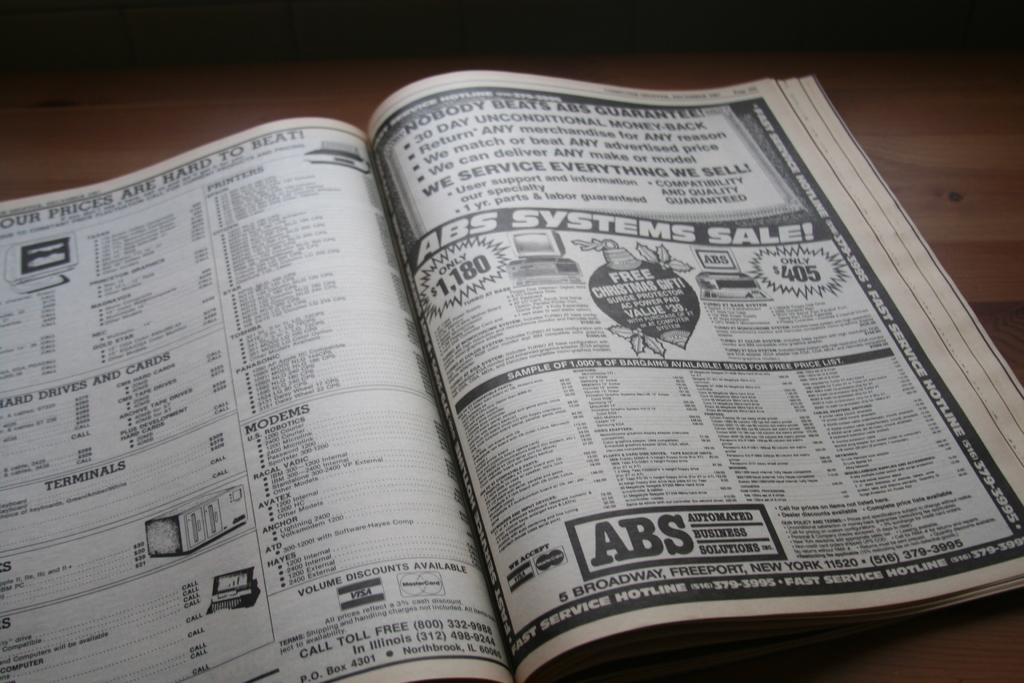<image>
Present a compact description of the photo's key features. Abs System Sale ad inside of a book including price list. 